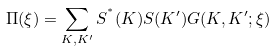Convert formula to latex. <formula><loc_0><loc_0><loc_500><loc_500>\Pi ( \xi ) = \sum _ { { K } , { K ^ { \prime } } } S ^ { ^ { * } } ( { K } ) S ( { K ^ { \prime } } ) G ( { K } , { K ^ { \prime } } ; \xi )</formula> 